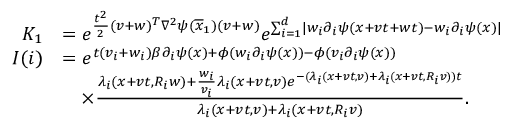<formula> <loc_0><loc_0><loc_500><loc_500>\begin{array} { r l } { K _ { 1 } } & { = e ^ { \frac { t ^ { 2 } } { 2 } ( v + w ) ^ { T } \nabla ^ { 2 } \psi ( \overline { x } _ { 1 } ) ( v + w ) } e ^ { \sum _ { i = 1 } ^ { d } | w _ { i } \partial _ { i } \psi ( x + v t + w t ) - w _ { i } \partial _ { i } \psi ( x ) | } } \\ { I ( i ) } & { = e ^ { t ( v _ { i } + w _ { i } ) \beta \partial _ { i } \psi ( x ) + \phi ( w _ { i } \partial _ { i } \psi ( x ) ) - \phi ( v _ { i } \partial _ { i } \psi ( x ) ) } } \\ & { \quad \times \frac { \lambda _ { i } ( x + v t , R _ { i } w ) + \frac { w _ { i } } { v _ { i } } \lambda _ { i } ( x + v t , v ) e ^ { - ( \lambda _ { i } ( x + v t , v ) + \lambda _ { i } ( x + v t , R _ { i } v ) ) t } } { \lambda _ { i } ( x + v t , v ) + \lambda _ { i } ( x + v t , R _ { i } v ) } . } \end{array}</formula> 